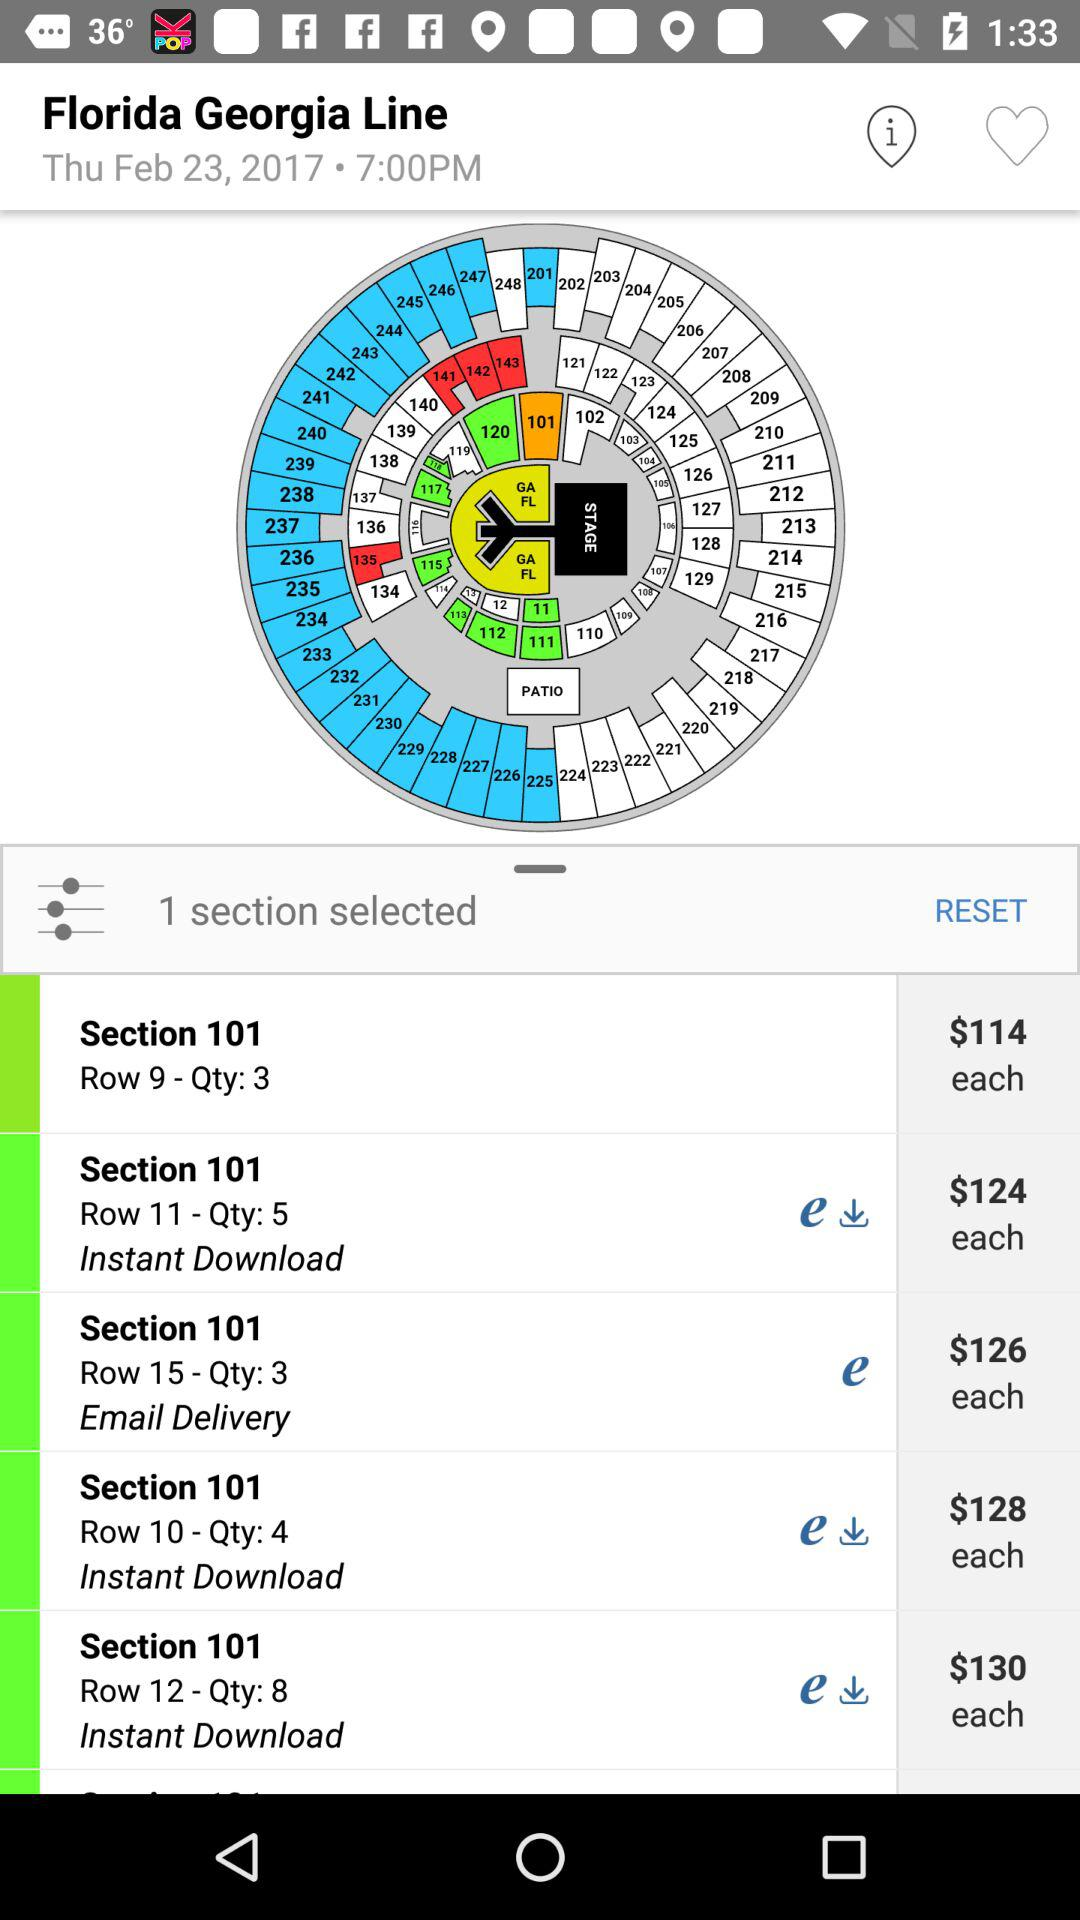What is the given date? The given date is Thursday, February 23, 2017. 